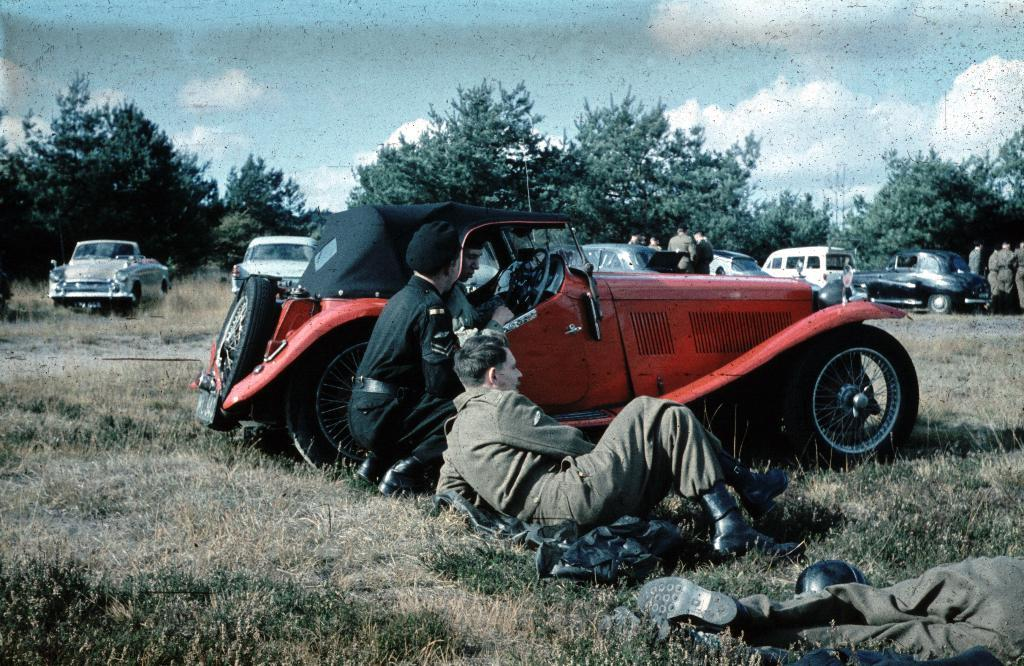What vehicle is present in the image? There is a jeep in the image. What are the two men in the center of the image doing? The men are on the floor in the image. What can be seen in the background of the image? There are cars, trees, and people in the background of the image. How much does the receipt weigh in the image? There is no receipt present in the image, so it is not possible to determine its weight. 